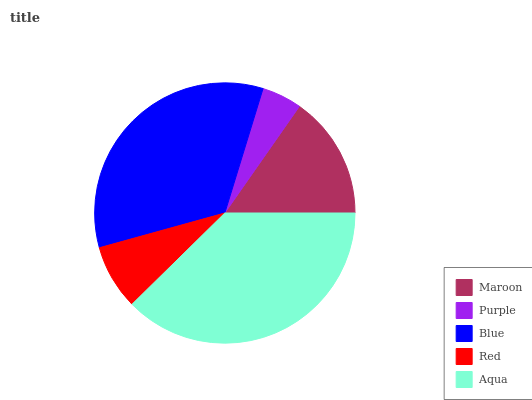Is Purple the minimum?
Answer yes or no. Yes. Is Aqua the maximum?
Answer yes or no. Yes. Is Blue the minimum?
Answer yes or no. No. Is Blue the maximum?
Answer yes or no. No. Is Blue greater than Purple?
Answer yes or no. Yes. Is Purple less than Blue?
Answer yes or no. Yes. Is Purple greater than Blue?
Answer yes or no. No. Is Blue less than Purple?
Answer yes or no. No. Is Maroon the high median?
Answer yes or no. Yes. Is Maroon the low median?
Answer yes or no. Yes. Is Red the high median?
Answer yes or no. No. Is Purple the low median?
Answer yes or no. No. 